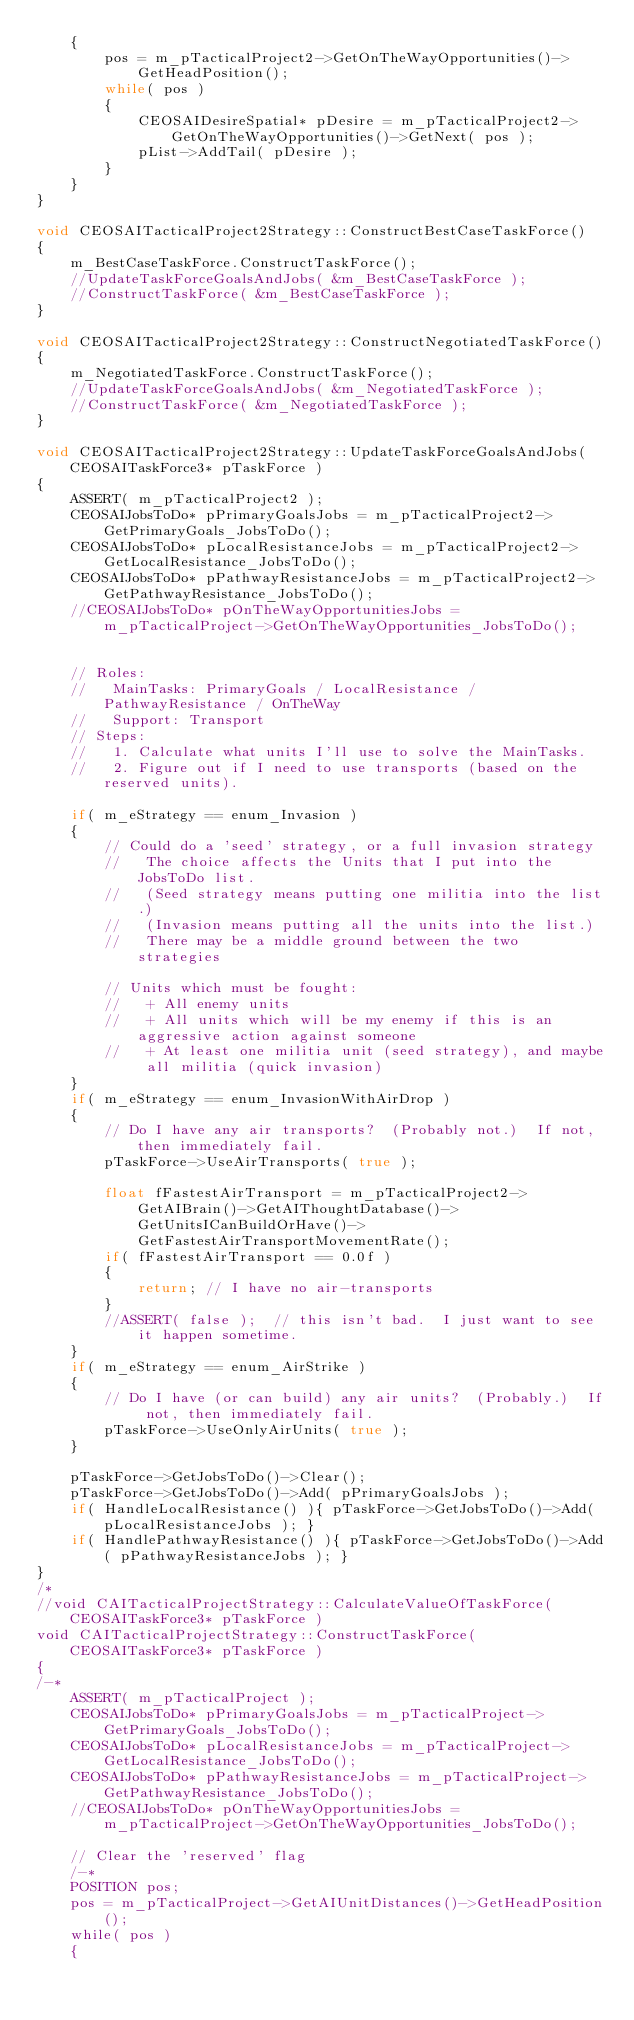<code> <loc_0><loc_0><loc_500><loc_500><_C++_>	{
		pos = m_pTacticalProject2->GetOnTheWayOpportunities()->GetHeadPosition();
		while( pos )
		{
			CEOSAIDesireSpatial* pDesire = m_pTacticalProject2->GetOnTheWayOpportunities()->GetNext( pos );
			pList->AddTail( pDesire );
		}
	}
}

void CEOSAITacticalProject2Strategy::ConstructBestCaseTaskForce()
{
	m_BestCaseTaskForce.ConstructTaskForce();
	//UpdateTaskForceGoalsAndJobs( &m_BestCaseTaskForce );
	//ConstructTaskForce( &m_BestCaseTaskForce );
}

void CEOSAITacticalProject2Strategy::ConstructNegotiatedTaskForce()
{
	m_NegotiatedTaskForce.ConstructTaskForce();
	//UpdateTaskForceGoalsAndJobs( &m_NegotiatedTaskForce );
	//ConstructTaskForce( &m_NegotiatedTaskForce );
}

void CEOSAITacticalProject2Strategy::UpdateTaskForceGoalsAndJobs( CEOSAITaskForce3* pTaskForce )
{
	ASSERT( m_pTacticalProject2 );
	CEOSAIJobsToDo* pPrimaryGoalsJobs = m_pTacticalProject2->GetPrimaryGoals_JobsToDo();
	CEOSAIJobsToDo* pLocalResistanceJobs = m_pTacticalProject2->GetLocalResistance_JobsToDo();
	CEOSAIJobsToDo* pPathwayResistanceJobs = m_pTacticalProject2->GetPathwayResistance_JobsToDo();
	//CEOSAIJobsToDo* pOnTheWayOpportunitiesJobs = m_pTacticalProject->GetOnTheWayOpportunities_JobsToDo();


	// Roles:
	//   MainTasks: PrimaryGoals / LocalResistance / PathwayResistance / OnTheWay
	//   Support: Transport
	// Steps:
	//   1. Calculate what units I'll use to solve the MainTasks.
	//   2. Figure out if I need to use transports (based on the reserved units).

	if( m_eStrategy == enum_Invasion )
	{
		// Could do a 'seed' strategy, or a full invasion strategy
		//   The choice affects the Units that I put into the JobsToDo list.
		//   (Seed strategy means putting one militia into the list.)
		//   (Invasion means putting all the units into the list.)
		//   There may be a middle ground between the two strategies

		// Units which must be fought:
		//   + All enemy units
		//   + All units which will be my enemy if this is an aggressive action against someone
		//   + At least one militia unit (seed strategy), and maybe all militia (quick invasion)
	}
	if( m_eStrategy == enum_InvasionWithAirDrop )
	{
		// Do I have any air transports?  (Probably not.)  If not, then immediately fail.
		pTaskForce->UseAirTransports( true );

		float fFastestAirTransport = m_pTacticalProject2->GetAIBrain()->GetAIThoughtDatabase()->GetUnitsICanBuildOrHave()->GetFastestAirTransportMovementRate();
		if( fFastestAirTransport == 0.0f )
		{
			return; // I have no air-transports
		}
		//ASSERT( false );  // this isn't bad.  I just want to see it happen sometime.
	}
	if( m_eStrategy == enum_AirStrike )
	{
		// Do I have (or can build) any air units?  (Probably.)  If not, then immediately fail.
		pTaskForce->UseOnlyAirUnits( true );
	}

	pTaskForce->GetJobsToDo()->Clear();
	pTaskForce->GetJobsToDo()->Add( pPrimaryGoalsJobs );
	if( HandleLocalResistance() ){ pTaskForce->GetJobsToDo()->Add( pLocalResistanceJobs ); }
	if( HandlePathwayResistance() ){ pTaskForce->GetJobsToDo()->Add( pPathwayResistanceJobs ); }
}
/*
//void CAITacticalProjectStrategy::CalculateValueOfTaskForce( CEOSAITaskForce3* pTaskForce )
void CAITacticalProjectStrategy::ConstructTaskForce( CEOSAITaskForce3* pTaskForce )
{
/-*
	ASSERT( m_pTacticalProject );
	CEOSAIJobsToDo* pPrimaryGoalsJobs = m_pTacticalProject->GetPrimaryGoals_JobsToDo();
	CEOSAIJobsToDo* pLocalResistanceJobs = m_pTacticalProject->GetLocalResistance_JobsToDo();
	CEOSAIJobsToDo* pPathwayResistanceJobs = m_pTacticalProject->GetPathwayResistance_JobsToDo();
	//CEOSAIJobsToDo* pOnTheWayOpportunitiesJobs = m_pTacticalProject->GetOnTheWayOpportunities_JobsToDo();

	// Clear the 'reserved' flag
	/-*
	POSITION pos;
	pos = m_pTacticalProject->GetAIUnitDistances()->GetHeadPosition();
	while( pos )
	{</code> 